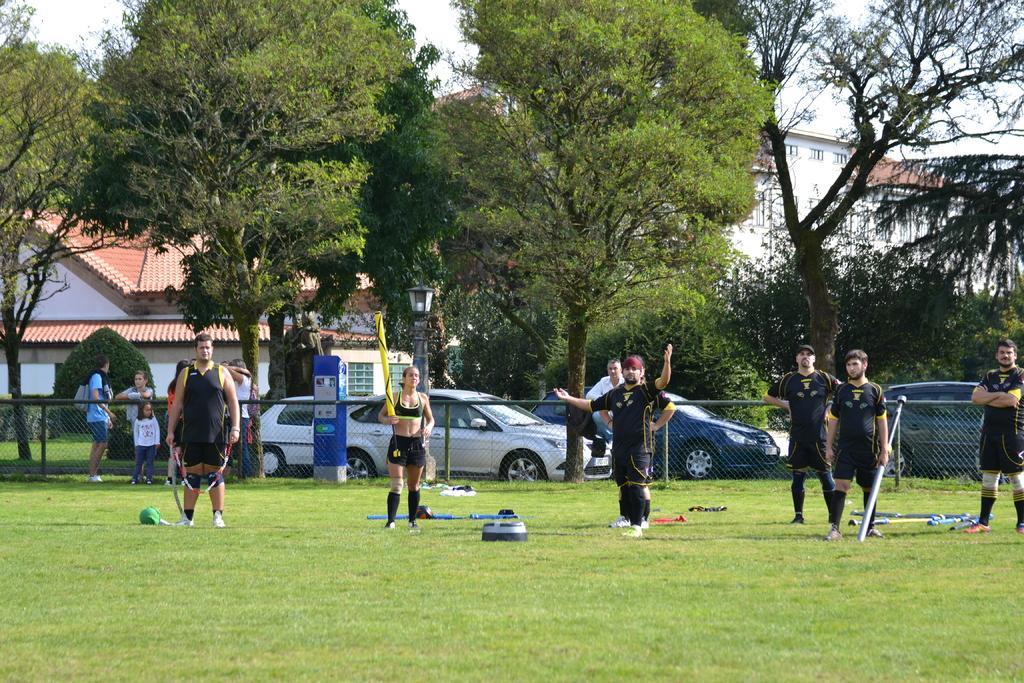Describe this image in one or two sentences. In this image we can see few persons are standing on the grass on the ground and among them few persons are holding objects in their hands. We can see clothes and objects on the grass. In the background few persons are standing at the fence, vehicles, trees, buildings, plants and sky. 